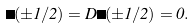<formula> <loc_0><loc_0><loc_500><loc_500>\Lambda ( \pm 1 / 2 ) = D \Lambda ( \pm 1 / 2 ) = 0 .</formula> 